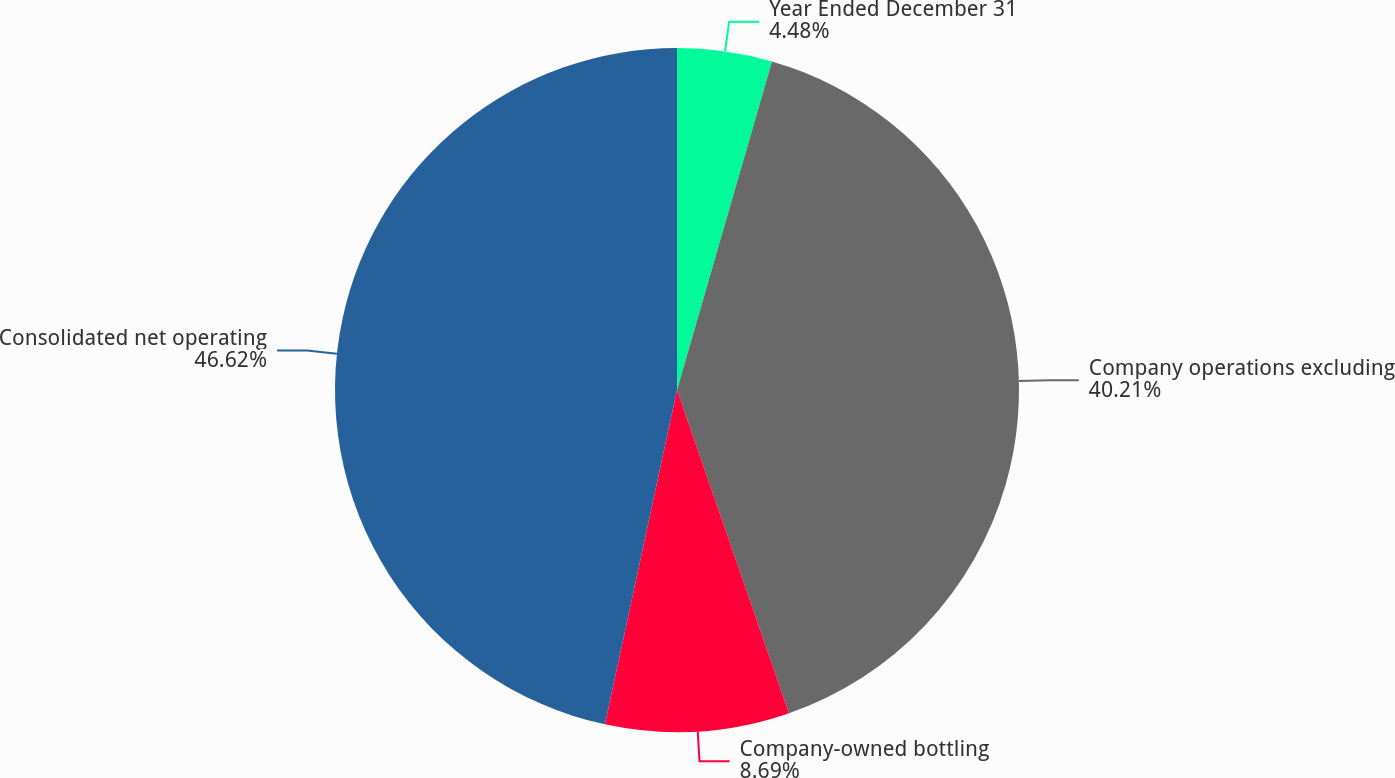<chart> <loc_0><loc_0><loc_500><loc_500><pie_chart><fcel>Year Ended December 31<fcel>Company operations excluding<fcel>Company-owned bottling<fcel>Consolidated net operating<nl><fcel>4.48%<fcel>40.21%<fcel>8.69%<fcel>46.62%<nl></chart> 